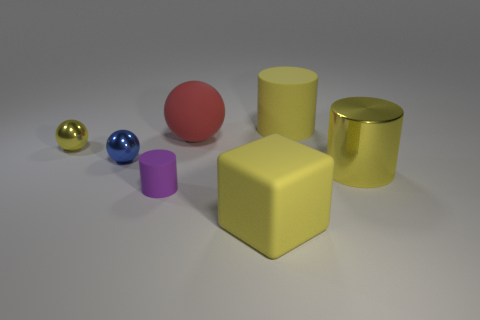How many metal things are either tiny gray spheres or yellow things?
Give a very brief answer. 2. Is there another sphere made of the same material as the small yellow sphere?
Your answer should be compact. Yes. What number of objects are either things behind the matte block or things behind the purple cylinder?
Ensure brevity in your answer.  6. There is a large matte thing that is on the left side of the yellow matte cube; is its color the same as the small matte object?
Provide a short and direct response. No. How many other objects are the same color as the large ball?
Provide a succinct answer. 0. What is the tiny blue ball made of?
Offer a terse response. Metal. Does the rubber cylinder on the left side of the matte block have the same size as the matte ball?
Ensure brevity in your answer.  No. Are there any other things that are the same size as the purple matte cylinder?
Offer a terse response. Yes. What is the size of the other matte thing that is the same shape as the small blue object?
Keep it short and to the point. Large. Is the number of purple matte objects on the left side of the tiny yellow object the same as the number of small metallic objects to the left of the yellow block?
Ensure brevity in your answer.  No. 